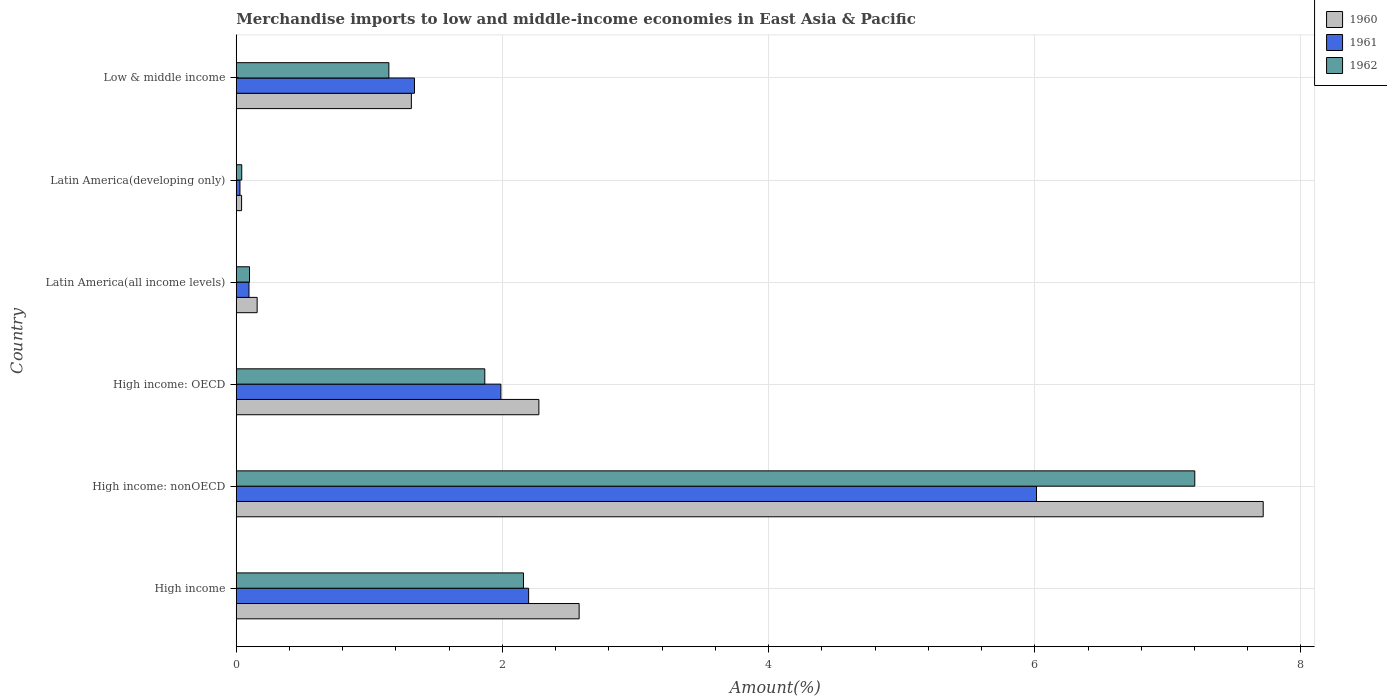How many different coloured bars are there?
Your answer should be compact. 3. How many bars are there on the 6th tick from the bottom?
Your answer should be very brief. 3. What is the label of the 4th group of bars from the top?
Offer a very short reply. High income: OECD. What is the percentage of amount earned from merchandise imports in 1960 in Latin America(developing only)?
Provide a succinct answer. 0.04. Across all countries, what is the maximum percentage of amount earned from merchandise imports in 1961?
Provide a short and direct response. 6.01. Across all countries, what is the minimum percentage of amount earned from merchandise imports in 1961?
Keep it short and to the point. 0.03. In which country was the percentage of amount earned from merchandise imports in 1961 maximum?
Provide a succinct answer. High income: nonOECD. In which country was the percentage of amount earned from merchandise imports in 1962 minimum?
Your response must be concise. Latin America(developing only). What is the total percentage of amount earned from merchandise imports in 1962 in the graph?
Your answer should be compact. 12.52. What is the difference between the percentage of amount earned from merchandise imports in 1960 in Latin America(developing only) and that in Low & middle income?
Give a very brief answer. -1.28. What is the difference between the percentage of amount earned from merchandise imports in 1962 in High income: OECD and the percentage of amount earned from merchandise imports in 1960 in Latin America(all income levels)?
Provide a short and direct response. 1.71. What is the average percentage of amount earned from merchandise imports in 1961 per country?
Your response must be concise. 1.94. What is the difference between the percentage of amount earned from merchandise imports in 1961 and percentage of amount earned from merchandise imports in 1960 in Latin America(all income levels)?
Your answer should be compact. -0.06. In how many countries, is the percentage of amount earned from merchandise imports in 1960 greater than 1.2000000000000002 %?
Offer a very short reply. 4. What is the ratio of the percentage of amount earned from merchandise imports in 1960 in High income: nonOECD to that in Low & middle income?
Provide a short and direct response. 5.86. What is the difference between the highest and the second highest percentage of amount earned from merchandise imports in 1960?
Your answer should be very brief. 5.14. What is the difference between the highest and the lowest percentage of amount earned from merchandise imports in 1960?
Provide a short and direct response. 7.68. Is it the case that in every country, the sum of the percentage of amount earned from merchandise imports in 1961 and percentage of amount earned from merchandise imports in 1962 is greater than the percentage of amount earned from merchandise imports in 1960?
Keep it short and to the point. Yes. How many bars are there?
Offer a very short reply. 18. How many countries are there in the graph?
Keep it short and to the point. 6. What is the difference between two consecutive major ticks on the X-axis?
Provide a short and direct response. 2. Does the graph contain grids?
Keep it short and to the point. Yes. Where does the legend appear in the graph?
Your answer should be compact. Top right. What is the title of the graph?
Offer a very short reply. Merchandise imports to low and middle-income economies in East Asia & Pacific. What is the label or title of the X-axis?
Give a very brief answer. Amount(%). What is the label or title of the Y-axis?
Give a very brief answer. Country. What is the Amount(%) in 1960 in High income?
Provide a short and direct response. 2.58. What is the Amount(%) of 1961 in High income?
Offer a terse response. 2.2. What is the Amount(%) in 1962 in High income?
Ensure brevity in your answer.  2.16. What is the Amount(%) of 1960 in High income: nonOECD?
Your answer should be very brief. 7.72. What is the Amount(%) of 1961 in High income: nonOECD?
Your answer should be compact. 6.01. What is the Amount(%) in 1962 in High income: nonOECD?
Ensure brevity in your answer.  7.2. What is the Amount(%) in 1960 in High income: OECD?
Offer a very short reply. 2.27. What is the Amount(%) in 1961 in High income: OECD?
Offer a terse response. 1.99. What is the Amount(%) of 1962 in High income: OECD?
Your response must be concise. 1.87. What is the Amount(%) in 1960 in Latin America(all income levels)?
Your answer should be compact. 0.16. What is the Amount(%) of 1961 in Latin America(all income levels)?
Give a very brief answer. 0.1. What is the Amount(%) of 1962 in Latin America(all income levels)?
Offer a very short reply. 0.1. What is the Amount(%) in 1960 in Latin America(developing only)?
Offer a terse response. 0.04. What is the Amount(%) in 1961 in Latin America(developing only)?
Offer a terse response. 0.03. What is the Amount(%) of 1962 in Latin America(developing only)?
Your answer should be very brief. 0.04. What is the Amount(%) of 1960 in Low & middle income?
Ensure brevity in your answer.  1.32. What is the Amount(%) in 1961 in Low & middle income?
Provide a succinct answer. 1.34. What is the Amount(%) of 1962 in Low & middle income?
Your answer should be very brief. 1.15. Across all countries, what is the maximum Amount(%) of 1960?
Provide a succinct answer. 7.72. Across all countries, what is the maximum Amount(%) in 1961?
Make the answer very short. 6.01. Across all countries, what is the maximum Amount(%) of 1962?
Keep it short and to the point. 7.2. Across all countries, what is the minimum Amount(%) in 1960?
Offer a terse response. 0.04. Across all countries, what is the minimum Amount(%) in 1961?
Offer a terse response. 0.03. Across all countries, what is the minimum Amount(%) in 1962?
Offer a terse response. 0.04. What is the total Amount(%) of 1960 in the graph?
Give a very brief answer. 14.08. What is the total Amount(%) of 1961 in the graph?
Make the answer very short. 11.66. What is the total Amount(%) in 1962 in the graph?
Offer a terse response. 12.52. What is the difference between the Amount(%) of 1960 in High income and that in High income: nonOECD?
Provide a short and direct response. -5.14. What is the difference between the Amount(%) in 1961 in High income and that in High income: nonOECD?
Your response must be concise. -3.82. What is the difference between the Amount(%) in 1962 in High income and that in High income: nonOECD?
Give a very brief answer. -5.04. What is the difference between the Amount(%) in 1960 in High income and that in High income: OECD?
Provide a succinct answer. 0.3. What is the difference between the Amount(%) in 1961 in High income and that in High income: OECD?
Offer a terse response. 0.21. What is the difference between the Amount(%) of 1962 in High income and that in High income: OECD?
Your answer should be compact. 0.29. What is the difference between the Amount(%) in 1960 in High income and that in Latin America(all income levels)?
Provide a succinct answer. 2.42. What is the difference between the Amount(%) in 1961 in High income and that in Latin America(all income levels)?
Provide a succinct answer. 2.1. What is the difference between the Amount(%) in 1962 in High income and that in Latin America(all income levels)?
Offer a very short reply. 2.06. What is the difference between the Amount(%) of 1960 in High income and that in Latin America(developing only)?
Provide a short and direct response. 2.54. What is the difference between the Amount(%) in 1961 in High income and that in Latin America(developing only)?
Make the answer very short. 2.17. What is the difference between the Amount(%) of 1962 in High income and that in Latin America(developing only)?
Your response must be concise. 2.12. What is the difference between the Amount(%) of 1960 in High income and that in Low & middle income?
Keep it short and to the point. 1.26. What is the difference between the Amount(%) of 1961 in High income and that in Low & middle income?
Offer a very short reply. 0.86. What is the difference between the Amount(%) of 1962 in High income and that in Low & middle income?
Make the answer very short. 1.01. What is the difference between the Amount(%) of 1960 in High income: nonOECD and that in High income: OECD?
Provide a succinct answer. 5.44. What is the difference between the Amount(%) in 1961 in High income: nonOECD and that in High income: OECD?
Offer a terse response. 4.02. What is the difference between the Amount(%) of 1962 in High income: nonOECD and that in High income: OECD?
Ensure brevity in your answer.  5.33. What is the difference between the Amount(%) of 1960 in High income: nonOECD and that in Latin America(all income levels)?
Keep it short and to the point. 7.56. What is the difference between the Amount(%) of 1961 in High income: nonOECD and that in Latin America(all income levels)?
Offer a very short reply. 5.92. What is the difference between the Amount(%) in 1962 in High income: nonOECD and that in Latin America(all income levels)?
Your answer should be compact. 7.1. What is the difference between the Amount(%) in 1960 in High income: nonOECD and that in Latin America(developing only)?
Your answer should be compact. 7.68. What is the difference between the Amount(%) of 1961 in High income: nonOECD and that in Latin America(developing only)?
Ensure brevity in your answer.  5.99. What is the difference between the Amount(%) of 1962 in High income: nonOECD and that in Latin America(developing only)?
Provide a short and direct response. 7.16. What is the difference between the Amount(%) of 1960 in High income: nonOECD and that in Low & middle income?
Provide a succinct answer. 6.4. What is the difference between the Amount(%) of 1961 in High income: nonOECD and that in Low & middle income?
Ensure brevity in your answer.  4.67. What is the difference between the Amount(%) of 1962 in High income: nonOECD and that in Low & middle income?
Your answer should be compact. 6.06. What is the difference between the Amount(%) in 1960 in High income: OECD and that in Latin America(all income levels)?
Provide a succinct answer. 2.12. What is the difference between the Amount(%) in 1961 in High income: OECD and that in Latin America(all income levels)?
Give a very brief answer. 1.89. What is the difference between the Amount(%) in 1962 in High income: OECD and that in Latin America(all income levels)?
Your response must be concise. 1.77. What is the difference between the Amount(%) in 1960 in High income: OECD and that in Latin America(developing only)?
Give a very brief answer. 2.23. What is the difference between the Amount(%) in 1961 in High income: OECD and that in Latin America(developing only)?
Your answer should be very brief. 1.96. What is the difference between the Amount(%) in 1962 in High income: OECD and that in Latin America(developing only)?
Your answer should be very brief. 1.83. What is the difference between the Amount(%) of 1960 in High income: OECD and that in Low & middle income?
Offer a terse response. 0.96. What is the difference between the Amount(%) of 1961 in High income: OECD and that in Low & middle income?
Keep it short and to the point. 0.65. What is the difference between the Amount(%) in 1962 in High income: OECD and that in Low & middle income?
Provide a succinct answer. 0.72. What is the difference between the Amount(%) in 1960 in Latin America(all income levels) and that in Latin America(developing only)?
Offer a very short reply. 0.12. What is the difference between the Amount(%) of 1961 in Latin America(all income levels) and that in Latin America(developing only)?
Your answer should be compact. 0.07. What is the difference between the Amount(%) of 1962 in Latin America(all income levels) and that in Latin America(developing only)?
Give a very brief answer. 0.06. What is the difference between the Amount(%) of 1960 in Latin America(all income levels) and that in Low & middle income?
Your answer should be very brief. -1.16. What is the difference between the Amount(%) of 1961 in Latin America(all income levels) and that in Low & middle income?
Your answer should be compact. -1.24. What is the difference between the Amount(%) of 1962 in Latin America(all income levels) and that in Low & middle income?
Offer a terse response. -1.05. What is the difference between the Amount(%) of 1960 in Latin America(developing only) and that in Low & middle income?
Ensure brevity in your answer.  -1.28. What is the difference between the Amount(%) of 1961 in Latin America(developing only) and that in Low & middle income?
Offer a terse response. -1.31. What is the difference between the Amount(%) in 1962 in Latin America(developing only) and that in Low & middle income?
Make the answer very short. -1.11. What is the difference between the Amount(%) of 1960 in High income and the Amount(%) of 1961 in High income: nonOECD?
Keep it short and to the point. -3.44. What is the difference between the Amount(%) of 1960 in High income and the Amount(%) of 1962 in High income: nonOECD?
Make the answer very short. -4.63. What is the difference between the Amount(%) of 1961 in High income and the Amount(%) of 1962 in High income: nonOECD?
Offer a very short reply. -5.01. What is the difference between the Amount(%) of 1960 in High income and the Amount(%) of 1961 in High income: OECD?
Your response must be concise. 0.59. What is the difference between the Amount(%) of 1960 in High income and the Amount(%) of 1962 in High income: OECD?
Keep it short and to the point. 0.71. What is the difference between the Amount(%) of 1961 in High income and the Amount(%) of 1962 in High income: OECD?
Keep it short and to the point. 0.33. What is the difference between the Amount(%) in 1960 in High income and the Amount(%) in 1961 in Latin America(all income levels)?
Give a very brief answer. 2.48. What is the difference between the Amount(%) in 1960 in High income and the Amount(%) in 1962 in Latin America(all income levels)?
Your response must be concise. 2.48. What is the difference between the Amount(%) in 1961 in High income and the Amount(%) in 1962 in Latin America(all income levels)?
Provide a succinct answer. 2.1. What is the difference between the Amount(%) in 1960 in High income and the Amount(%) in 1961 in Latin America(developing only)?
Ensure brevity in your answer.  2.55. What is the difference between the Amount(%) of 1960 in High income and the Amount(%) of 1962 in Latin America(developing only)?
Provide a succinct answer. 2.54. What is the difference between the Amount(%) of 1961 in High income and the Amount(%) of 1962 in Latin America(developing only)?
Offer a terse response. 2.16. What is the difference between the Amount(%) of 1960 in High income and the Amount(%) of 1961 in Low & middle income?
Offer a very short reply. 1.24. What is the difference between the Amount(%) of 1960 in High income and the Amount(%) of 1962 in Low & middle income?
Provide a short and direct response. 1.43. What is the difference between the Amount(%) of 1961 in High income and the Amount(%) of 1962 in Low & middle income?
Offer a terse response. 1.05. What is the difference between the Amount(%) of 1960 in High income: nonOECD and the Amount(%) of 1961 in High income: OECD?
Your answer should be very brief. 5.73. What is the difference between the Amount(%) in 1960 in High income: nonOECD and the Amount(%) in 1962 in High income: OECD?
Your answer should be very brief. 5.85. What is the difference between the Amount(%) of 1961 in High income: nonOECD and the Amount(%) of 1962 in High income: OECD?
Offer a very short reply. 4.15. What is the difference between the Amount(%) in 1960 in High income: nonOECD and the Amount(%) in 1961 in Latin America(all income levels)?
Your response must be concise. 7.62. What is the difference between the Amount(%) of 1960 in High income: nonOECD and the Amount(%) of 1962 in Latin America(all income levels)?
Make the answer very short. 7.62. What is the difference between the Amount(%) of 1961 in High income: nonOECD and the Amount(%) of 1962 in Latin America(all income levels)?
Ensure brevity in your answer.  5.91. What is the difference between the Amount(%) in 1960 in High income: nonOECD and the Amount(%) in 1961 in Latin America(developing only)?
Offer a very short reply. 7.69. What is the difference between the Amount(%) of 1960 in High income: nonOECD and the Amount(%) of 1962 in Latin America(developing only)?
Offer a very short reply. 7.67. What is the difference between the Amount(%) in 1961 in High income: nonOECD and the Amount(%) in 1962 in Latin America(developing only)?
Provide a short and direct response. 5.97. What is the difference between the Amount(%) of 1960 in High income: nonOECD and the Amount(%) of 1961 in Low & middle income?
Make the answer very short. 6.38. What is the difference between the Amount(%) in 1960 in High income: nonOECD and the Amount(%) in 1962 in Low & middle income?
Your answer should be very brief. 6.57. What is the difference between the Amount(%) of 1961 in High income: nonOECD and the Amount(%) of 1962 in Low & middle income?
Your answer should be compact. 4.87. What is the difference between the Amount(%) in 1960 in High income: OECD and the Amount(%) in 1961 in Latin America(all income levels)?
Your response must be concise. 2.18. What is the difference between the Amount(%) of 1960 in High income: OECD and the Amount(%) of 1962 in Latin America(all income levels)?
Your answer should be compact. 2.17. What is the difference between the Amount(%) in 1961 in High income: OECD and the Amount(%) in 1962 in Latin America(all income levels)?
Give a very brief answer. 1.89. What is the difference between the Amount(%) in 1960 in High income: OECD and the Amount(%) in 1961 in Latin America(developing only)?
Provide a short and direct response. 2.25. What is the difference between the Amount(%) in 1960 in High income: OECD and the Amount(%) in 1962 in Latin America(developing only)?
Make the answer very short. 2.23. What is the difference between the Amount(%) in 1961 in High income: OECD and the Amount(%) in 1962 in Latin America(developing only)?
Your response must be concise. 1.95. What is the difference between the Amount(%) in 1960 in High income: OECD and the Amount(%) in 1961 in Low & middle income?
Your response must be concise. 0.93. What is the difference between the Amount(%) of 1960 in High income: OECD and the Amount(%) of 1962 in Low & middle income?
Your response must be concise. 1.13. What is the difference between the Amount(%) in 1961 in High income: OECD and the Amount(%) in 1962 in Low & middle income?
Provide a succinct answer. 0.84. What is the difference between the Amount(%) in 1960 in Latin America(all income levels) and the Amount(%) in 1961 in Latin America(developing only)?
Your answer should be very brief. 0.13. What is the difference between the Amount(%) of 1960 in Latin America(all income levels) and the Amount(%) of 1962 in Latin America(developing only)?
Provide a succinct answer. 0.12. What is the difference between the Amount(%) of 1961 in Latin America(all income levels) and the Amount(%) of 1962 in Latin America(developing only)?
Keep it short and to the point. 0.05. What is the difference between the Amount(%) in 1960 in Latin America(all income levels) and the Amount(%) in 1961 in Low & middle income?
Your answer should be very brief. -1.18. What is the difference between the Amount(%) in 1960 in Latin America(all income levels) and the Amount(%) in 1962 in Low & middle income?
Give a very brief answer. -0.99. What is the difference between the Amount(%) of 1961 in Latin America(all income levels) and the Amount(%) of 1962 in Low & middle income?
Provide a succinct answer. -1.05. What is the difference between the Amount(%) in 1960 in Latin America(developing only) and the Amount(%) in 1961 in Low & middle income?
Your response must be concise. -1.3. What is the difference between the Amount(%) of 1960 in Latin America(developing only) and the Amount(%) of 1962 in Low & middle income?
Give a very brief answer. -1.11. What is the difference between the Amount(%) in 1961 in Latin America(developing only) and the Amount(%) in 1962 in Low & middle income?
Your answer should be very brief. -1.12. What is the average Amount(%) of 1960 per country?
Your response must be concise. 2.35. What is the average Amount(%) of 1961 per country?
Keep it short and to the point. 1.94. What is the average Amount(%) in 1962 per country?
Offer a very short reply. 2.09. What is the difference between the Amount(%) of 1960 and Amount(%) of 1961 in High income?
Offer a terse response. 0.38. What is the difference between the Amount(%) of 1960 and Amount(%) of 1962 in High income?
Your answer should be compact. 0.42. What is the difference between the Amount(%) in 1961 and Amount(%) in 1962 in High income?
Offer a very short reply. 0.04. What is the difference between the Amount(%) in 1960 and Amount(%) in 1961 in High income: nonOECD?
Offer a very short reply. 1.7. What is the difference between the Amount(%) of 1960 and Amount(%) of 1962 in High income: nonOECD?
Provide a short and direct response. 0.51. What is the difference between the Amount(%) of 1961 and Amount(%) of 1962 in High income: nonOECD?
Provide a succinct answer. -1.19. What is the difference between the Amount(%) in 1960 and Amount(%) in 1961 in High income: OECD?
Provide a short and direct response. 0.29. What is the difference between the Amount(%) of 1960 and Amount(%) of 1962 in High income: OECD?
Your answer should be compact. 0.41. What is the difference between the Amount(%) in 1961 and Amount(%) in 1962 in High income: OECD?
Your response must be concise. 0.12. What is the difference between the Amount(%) of 1960 and Amount(%) of 1961 in Latin America(all income levels)?
Keep it short and to the point. 0.06. What is the difference between the Amount(%) of 1960 and Amount(%) of 1962 in Latin America(all income levels)?
Offer a terse response. 0.06. What is the difference between the Amount(%) of 1961 and Amount(%) of 1962 in Latin America(all income levels)?
Make the answer very short. -0. What is the difference between the Amount(%) of 1960 and Amount(%) of 1961 in Latin America(developing only)?
Your response must be concise. 0.01. What is the difference between the Amount(%) of 1960 and Amount(%) of 1962 in Latin America(developing only)?
Provide a short and direct response. -0. What is the difference between the Amount(%) of 1961 and Amount(%) of 1962 in Latin America(developing only)?
Provide a short and direct response. -0.01. What is the difference between the Amount(%) of 1960 and Amount(%) of 1961 in Low & middle income?
Make the answer very short. -0.02. What is the difference between the Amount(%) in 1960 and Amount(%) in 1962 in Low & middle income?
Make the answer very short. 0.17. What is the difference between the Amount(%) in 1961 and Amount(%) in 1962 in Low & middle income?
Provide a short and direct response. 0.19. What is the ratio of the Amount(%) in 1960 in High income to that in High income: nonOECD?
Provide a short and direct response. 0.33. What is the ratio of the Amount(%) of 1961 in High income to that in High income: nonOECD?
Ensure brevity in your answer.  0.37. What is the ratio of the Amount(%) in 1962 in High income to that in High income: nonOECD?
Ensure brevity in your answer.  0.3. What is the ratio of the Amount(%) of 1960 in High income to that in High income: OECD?
Provide a succinct answer. 1.13. What is the ratio of the Amount(%) of 1961 in High income to that in High income: OECD?
Offer a terse response. 1.1. What is the ratio of the Amount(%) of 1962 in High income to that in High income: OECD?
Your response must be concise. 1.16. What is the ratio of the Amount(%) in 1960 in High income to that in Latin America(all income levels)?
Your answer should be compact. 16.42. What is the ratio of the Amount(%) in 1961 in High income to that in Latin America(all income levels)?
Offer a terse response. 22.93. What is the ratio of the Amount(%) in 1962 in High income to that in Latin America(all income levels)?
Your answer should be compact. 21.66. What is the ratio of the Amount(%) of 1960 in High income to that in Latin America(developing only)?
Offer a very short reply. 64.25. What is the ratio of the Amount(%) of 1961 in High income to that in Latin America(developing only)?
Provide a short and direct response. 79.06. What is the ratio of the Amount(%) in 1962 in High income to that in Latin America(developing only)?
Offer a very short reply. 52.23. What is the ratio of the Amount(%) in 1960 in High income to that in Low & middle income?
Your response must be concise. 1.96. What is the ratio of the Amount(%) of 1961 in High income to that in Low & middle income?
Keep it short and to the point. 1.64. What is the ratio of the Amount(%) in 1962 in High income to that in Low & middle income?
Your answer should be very brief. 1.88. What is the ratio of the Amount(%) in 1960 in High income: nonOECD to that in High income: OECD?
Keep it short and to the point. 3.39. What is the ratio of the Amount(%) of 1961 in High income: nonOECD to that in High income: OECD?
Your answer should be very brief. 3.02. What is the ratio of the Amount(%) of 1962 in High income: nonOECD to that in High income: OECD?
Provide a succinct answer. 3.86. What is the ratio of the Amount(%) in 1960 in High income: nonOECD to that in Latin America(all income levels)?
Offer a very short reply. 49.18. What is the ratio of the Amount(%) in 1961 in High income: nonOECD to that in Latin America(all income levels)?
Your answer should be very brief. 62.77. What is the ratio of the Amount(%) in 1962 in High income: nonOECD to that in Latin America(all income levels)?
Your answer should be very brief. 72.3. What is the ratio of the Amount(%) of 1960 in High income: nonOECD to that in Latin America(developing only)?
Your answer should be compact. 192.42. What is the ratio of the Amount(%) of 1961 in High income: nonOECD to that in Latin America(developing only)?
Give a very brief answer. 216.41. What is the ratio of the Amount(%) in 1962 in High income: nonOECD to that in Latin America(developing only)?
Offer a terse response. 174.29. What is the ratio of the Amount(%) of 1960 in High income: nonOECD to that in Low & middle income?
Provide a succinct answer. 5.86. What is the ratio of the Amount(%) of 1961 in High income: nonOECD to that in Low & middle income?
Your response must be concise. 4.49. What is the ratio of the Amount(%) in 1962 in High income: nonOECD to that in Low & middle income?
Give a very brief answer. 6.28. What is the ratio of the Amount(%) of 1960 in High income: OECD to that in Latin America(all income levels)?
Offer a very short reply. 14.49. What is the ratio of the Amount(%) in 1961 in High income: OECD to that in Latin America(all income levels)?
Your answer should be very brief. 20.76. What is the ratio of the Amount(%) in 1962 in High income: OECD to that in Latin America(all income levels)?
Ensure brevity in your answer.  18.75. What is the ratio of the Amount(%) in 1960 in High income: OECD to that in Latin America(developing only)?
Offer a terse response. 56.7. What is the ratio of the Amount(%) in 1961 in High income: OECD to that in Latin America(developing only)?
Your response must be concise. 71.56. What is the ratio of the Amount(%) in 1962 in High income: OECD to that in Latin America(developing only)?
Provide a short and direct response. 45.19. What is the ratio of the Amount(%) in 1960 in High income: OECD to that in Low & middle income?
Your response must be concise. 1.73. What is the ratio of the Amount(%) in 1961 in High income: OECD to that in Low & middle income?
Offer a very short reply. 1.48. What is the ratio of the Amount(%) of 1962 in High income: OECD to that in Low & middle income?
Your response must be concise. 1.63. What is the ratio of the Amount(%) of 1960 in Latin America(all income levels) to that in Latin America(developing only)?
Provide a succinct answer. 3.91. What is the ratio of the Amount(%) in 1961 in Latin America(all income levels) to that in Latin America(developing only)?
Give a very brief answer. 3.45. What is the ratio of the Amount(%) of 1962 in Latin America(all income levels) to that in Latin America(developing only)?
Make the answer very short. 2.41. What is the ratio of the Amount(%) in 1960 in Latin America(all income levels) to that in Low & middle income?
Keep it short and to the point. 0.12. What is the ratio of the Amount(%) in 1961 in Latin America(all income levels) to that in Low & middle income?
Ensure brevity in your answer.  0.07. What is the ratio of the Amount(%) of 1962 in Latin America(all income levels) to that in Low & middle income?
Your response must be concise. 0.09. What is the ratio of the Amount(%) of 1960 in Latin America(developing only) to that in Low & middle income?
Your answer should be very brief. 0.03. What is the ratio of the Amount(%) of 1961 in Latin America(developing only) to that in Low & middle income?
Your answer should be compact. 0.02. What is the ratio of the Amount(%) of 1962 in Latin America(developing only) to that in Low & middle income?
Make the answer very short. 0.04. What is the difference between the highest and the second highest Amount(%) in 1960?
Ensure brevity in your answer.  5.14. What is the difference between the highest and the second highest Amount(%) of 1961?
Ensure brevity in your answer.  3.82. What is the difference between the highest and the second highest Amount(%) of 1962?
Provide a succinct answer. 5.04. What is the difference between the highest and the lowest Amount(%) of 1960?
Your answer should be very brief. 7.68. What is the difference between the highest and the lowest Amount(%) in 1961?
Keep it short and to the point. 5.99. What is the difference between the highest and the lowest Amount(%) in 1962?
Keep it short and to the point. 7.16. 